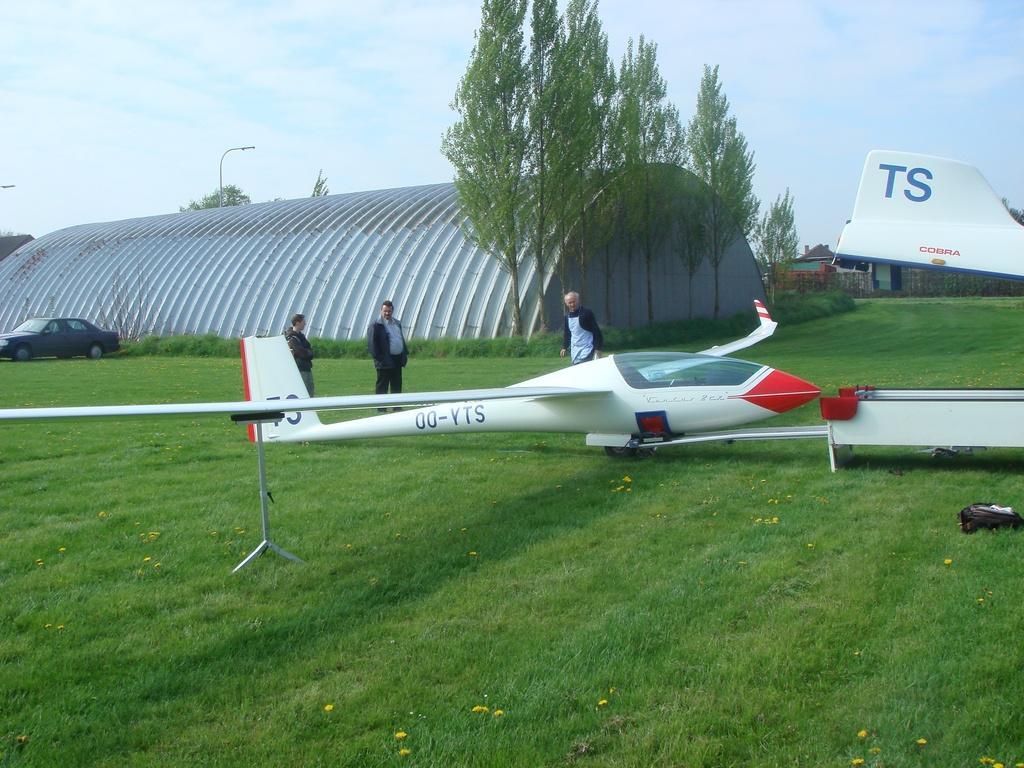Describe this image in one or two sentences. In this picture I can see three persons are standing on the grass, in the background it looks like a shed, beside it there are trees, on the left side I can see a car. At the top there is the sky. 